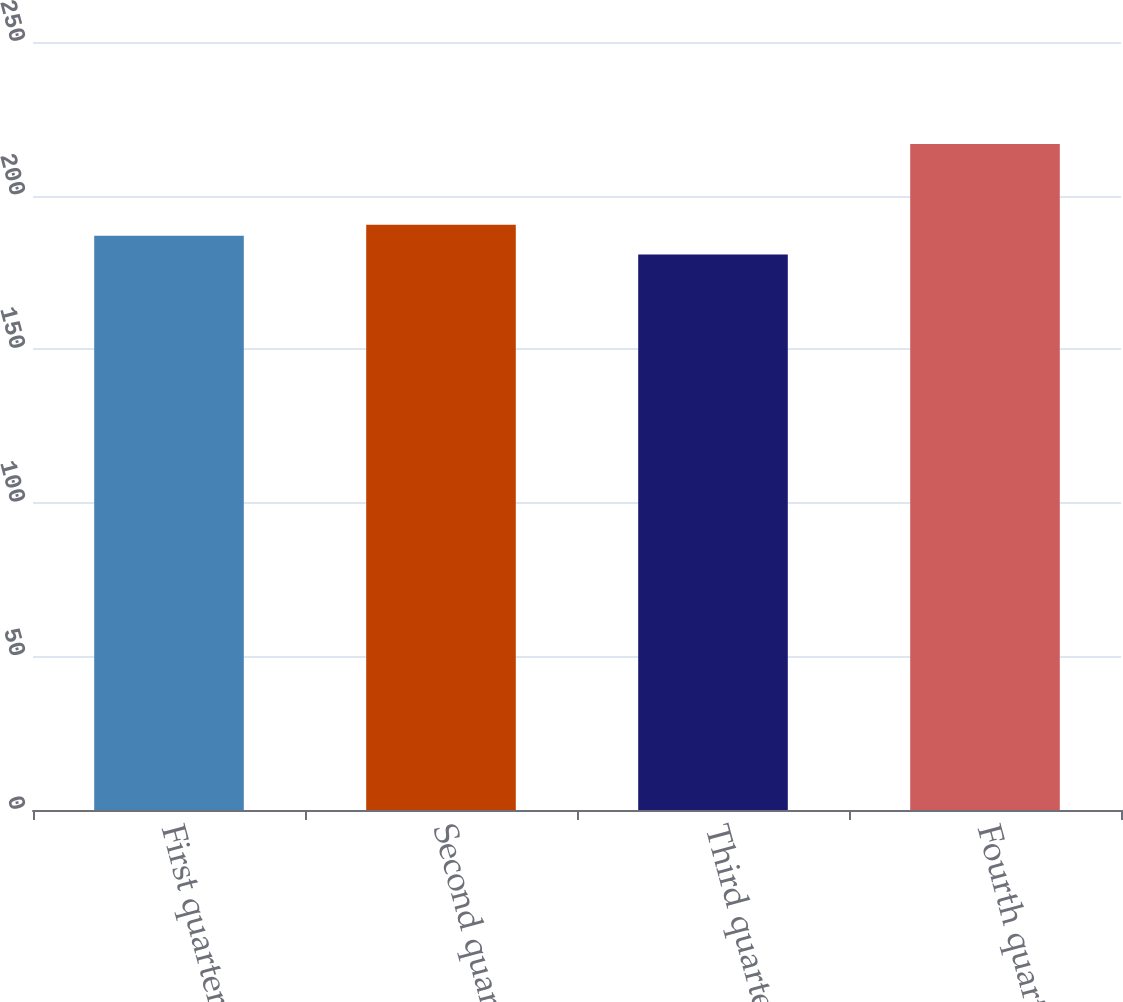Convert chart. <chart><loc_0><loc_0><loc_500><loc_500><bar_chart><fcel>First quarter<fcel>Second quarter<fcel>Third quarter<fcel>Fourth quarter<nl><fcel>186.91<fcel>190.5<fcel>180.86<fcel>216.76<nl></chart> 